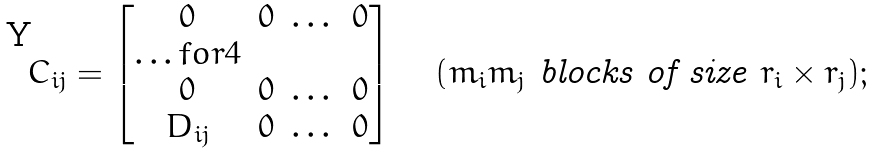Convert formula to latex. <formula><loc_0><loc_0><loc_500><loc_500>C _ { i j } = \begin{bmatrix} 0 & 0 & \dots & 0 \\ \hdots f o r { 4 } \\ 0 & 0 & \dots & 0 \\ D _ { i j } & 0 & \dots & 0 \\ \end{bmatrix} \quad ( m _ { i } m _ { j } \ \text {blocks of size } r _ { i } \times r _ { j } ) ;</formula> 